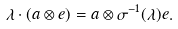<formula> <loc_0><loc_0><loc_500><loc_500>\lambda \cdot ( a \otimes e ) = a \otimes \sigma ^ { - 1 } ( \lambda ) e .</formula> 